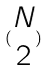Convert formula to latex. <formula><loc_0><loc_0><loc_500><loc_500>( \begin{matrix} N \\ 2 \end{matrix} )</formula> 